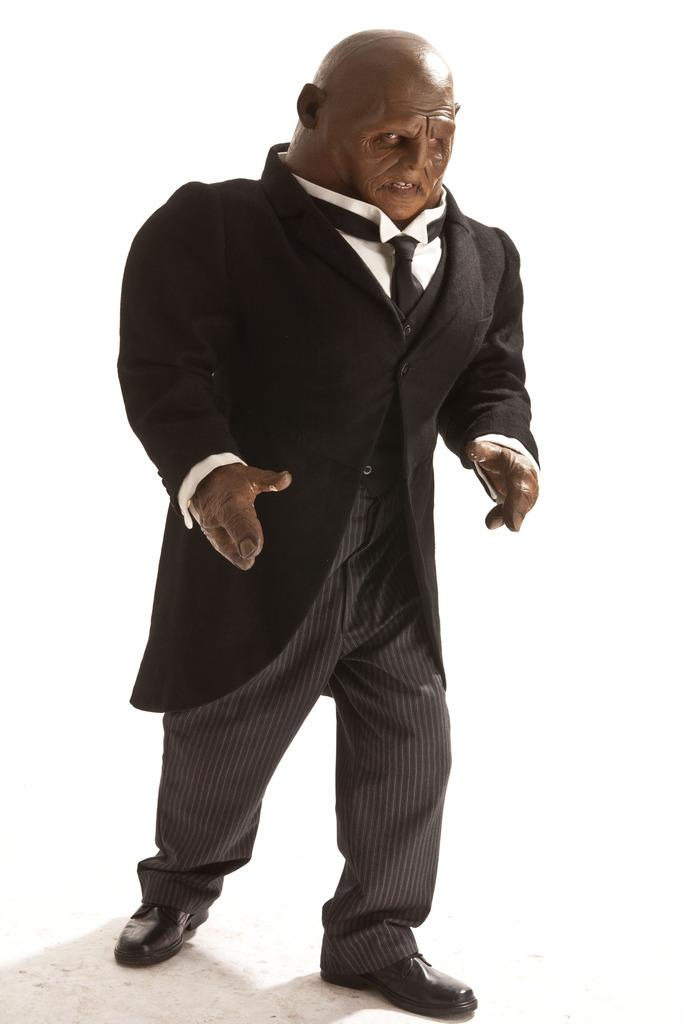What is the main subject of the image? There is a statue of a person in the image. What can be seen in the background of the image? The background of the image is white. What type of alarm is going off in the image? There is no alarm present in the image; it only features a statue of a person with a white background. 